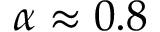<formula> <loc_0><loc_0><loc_500><loc_500>\alpha \approx 0 . 8</formula> 